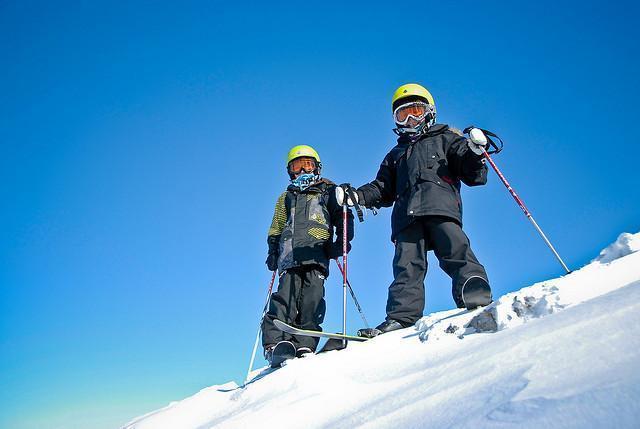How many people can be seen?
Give a very brief answer. 2. How many white horses are pulling the carriage?
Give a very brief answer. 0. 